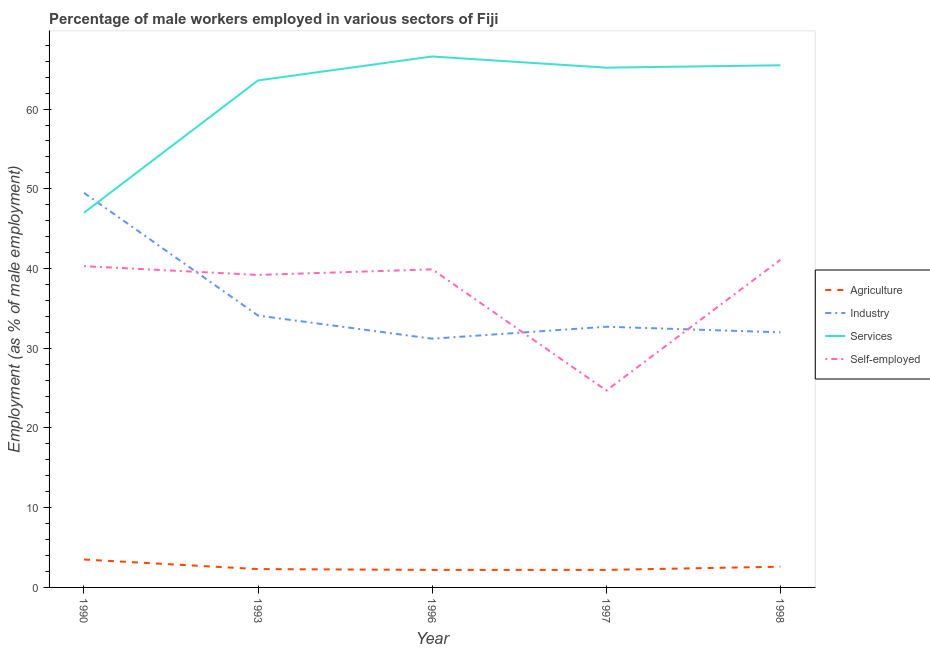What is the percentage of male workers in industry in 1996?
Provide a short and direct response. 31.2. Across all years, what is the maximum percentage of male workers in industry?
Keep it short and to the point. 49.5. Across all years, what is the minimum percentage of male workers in agriculture?
Your answer should be very brief. 2.2. In which year was the percentage of male workers in industry maximum?
Provide a succinct answer. 1990. What is the total percentage of male workers in industry in the graph?
Give a very brief answer. 179.5. What is the difference between the percentage of male workers in agriculture in 1990 and that in 1993?
Ensure brevity in your answer.  1.2. What is the difference between the percentage of self employed male workers in 1993 and the percentage of male workers in agriculture in 1996?
Make the answer very short. 37. What is the average percentage of male workers in services per year?
Make the answer very short. 61.58. In the year 1993, what is the difference between the percentage of male workers in services and percentage of male workers in agriculture?
Provide a short and direct response. 61.3. What is the ratio of the percentage of self employed male workers in 1993 to that in 1998?
Provide a short and direct response. 0.95. What is the difference between the highest and the second highest percentage of self employed male workers?
Give a very brief answer. 0.8. What is the difference between the highest and the lowest percentage of self employed male workers?
Offer a very short reply. 16.4. Is the sum of the percentage of self employed male workers in 1996 and 1998 greater than the maximum percentage of male workers in agriculture across all years?
Your answer should be very brief. Yes. Is it the case that in every year, the sum of the percentage of male workers in agriculture and percentage of male workers in industry is greater than the percentage of male workers in services?
Your answer should be very brief. No. Is the percentage of male workers in industry strictly greater than the percentage of self employed male workers over the years?
Keep it short and to the point. No. Is the percentage of self employed male workers strictly less than the percentage of male workers in industry over the years?
Your answer should be very brief. No. Are the values on the major ticks of Y-axis written in scientific E-notation?
Ensure brevity in your answer.  No. How many legend labels are there?
Your response must be concise. 4. What is the title of the graph?
Offer a very short reply. Percentage of male workers employed in various sectors of Fiji. What is the label or title of the X-axis?
Your response must be concise. Year. What is the label or title of the Y-axis?
Ensure brevity in your answer.  Employment (as % of male employment). What is the Employment (as % of male employment) of Agriculture in 1990?
Provide a short and direct response. 3.5. What is the Employment (as % of male employment) of Industry in 1990?
Make the answer very short. 49.5. What is the Employment (as % of male employment) in Self-employed in 1990?
Give a very brief answer. 40.3. What is the Employment (as % of male employment) in Agriculture in 1993?
Offer a very short reply. 2.3. What is the Employment (as % of male employment) of Industry in 1993?
Your response must be concise. 34.1. What is the Employment (as % of male employment) of Services in 1993?
Keep it short and to the point. 63.6. What is the Employment (as % of male employment) in Self-employed in 1993?
Your answer should be compact. 39.2. What is the Employment (as % of male employment) in Agriculture in 1996?
Provide a short and direct response. 2.2. What is the Employment (as % of male employment) in Industry in 1996?
Provide a succinct answer. 31.2. What is the Employment (as % of male employment) in Services in 1996?
Ensure brevity in your answer.  66.6. What is the Employment (as % of male employment) in Self-employed in 1996?
Your response must be concise. 39.9. What is the Employment (as % of male employment) of Agriculture in 1997?
Your response must be concise. 2.2. What is the Employment (as % of male employment) of Industry in 1997?
Give a very brief answer. 32.7. What is the Employment (as % of male employment) of Services in 1997?
Make the answer very short. 65.2. What is the Employment (as % of male employment) of Self-employed in 1997?
Offer a very short reply. 24.7. What is the Employment (as % of male employment) of Agriculture in 1998?
Provide a succinct answer. 2.6. What is the Employment (as % of male employment) of Industry in 1998?
Your response must be concise. 32. What is the Employment (as % of male employment) in Services in 1998?
Your answer should be compact. 65.5. What is the Employment (as % of male employment) of Self-employed in 1998?
Keep it short and to the point. 41.1. Across all years, what is the maximum Employment (as % of male employment) of Agriculture?
Keep it short and to the point. 3.5. Across all years, what is the maximum Employment (as % of male employment) in Industry?
Offer a terse response. 49.5. Across all years, what is the maximum Employment (as % of male employment) in Services?
Ensure brevity in your answer.  66.6. Across all years, what is the maximum Employment (as % of male employment) of Self-employed?
Offer a terse response. 41.1. Across all years, what is the minimum Employment (as % of male employment) of Agriculture?
Keep it short and to the point. 2.2. Across all years, what is the minimum Employment (as % of male employment) in Industry?
Offer a very short reply. 31.2. Across all years, what is the minimum Employment (as % of male employment) of Self-employed?
Keep it short and to the point. 24.7. What is the total Employment (as % of male employment) in Agriculture in the graph?
Your answer should be compact. 12.8. What is the total Employment (as % of male employment) in Industry in the graph?
Give a very brief answer. 179.5. What is the total Employment (as % of male employment) of Services in the graph?
Your response must be concise. 307.9. What is the total Employment (as % of male employment) in Self-employed in the graph?
Your answer should be very brief. 185.2. What is the difference between the Employment (as % of male employment) in Industry in 1990 and that in 1993?
Offer a very short reply. 15.4. What is the difference between the Employment (as % of male employment) of Services in 1990 and that in 1993?
Your answer should be very brief. -16.6. What is the difference between the Employment (as % of male employment) in Agriculture in 1990 and that in 1996?
Give a very brief answer. 1.3. What is the difference between the Employment (as % of male employment) of Services in 1990 and that in 1996?
Provide a short and direct response. -19.6. What is the difference between the Employment (as % of male employment) in Agriculture in 1990 and that in 1997?
Make the answer very short. 1.3. What is the difference between the Employment (as % of male employment) in Industry in 1990 and that in 1997?
Make the answer very short. 16.8. What is the difference between the Employment (as % of male employment) in Services in 1990 and that in 1997?
Offer a terse response. -18.2. What is the difference between the Employment (as % of male employment) in Self-employed in 1990 and that in 1997?
Give a very brief answer. 15.6. What is the difference between the Employment (as % of male employment) in Agriculture in 1990 and that in 1998?
Keep it short and to the point. 0.9. What is the difference between the Employment (as % of male employment) of Services in 1990 and that in 1998?
Keep it short and to the point. -18.5. What is the difference between the Employment (as % of male employment) in Self-employed in 1990 and that in 1998?
Offer a very short reply. -0.8. What is the difference between the Employment (as % of male employment) in Industry in 1993 and that in 1997?
Your response must be concise. 1.4. What is the difference between the Employment (as % of male employment) in Services in 1993 and that in 1997?
Make the answer very short. -1.6. What is the difference between the Employment (as % of male employment) in Self-employed in 1993 and that in 1997?
Provide a succinct answer. 14.5. What is the difference between the Employment (as % of male employment) in Agriculture in 1993 and that in 1998?
Make the answer very short. -0.3. What is the difference between the Employment (as % of male employment) in Services in 1993 and that in 1998?
Offer a terse response. -1.9. What is the difference between the Employment (as % of male employment) of Industry in 1996 and that in 1997?
Your response must be concise. -1.5. What is the difference between the Employment (as % of male employment) in Self-employed in 1996 and that in 1997?
Provide a short and direct response. 15.2. What is the difference between the Employment (as % of male employment) in Self-employed in 1996 and that in 1998?
Give a very brief answer. -1.2. What is the difference between the Employment (as % of male employment) in Industry in 1997 and that in 1998?
Your response must be concise. 0.7. What is the difference between the Employment (as % of male employment) of Self-employed in 1997 and that in 1998?
Give a very brief answer. -16.4. What is the difference between the Employment (as % of male employment) in Agriculture in 1990 and the Employment (as % of male employment) in Industry in 1993?
Your answer should be compact. -30.6. What is the difference between the Employment (as % of male employment) of Agriculture in 1990 and the Employment (as % of male employment) of Services in 1993?
Make the answer very short. -60.1. What is the difference between the Employment (as % of male employment) of Agriculture in 1990 and the Employment (as % of male employment) of Self-employed in 1993?
Provide a short and direct response. -35.7. What is the difference between the Employment (as % of male employment) in Industry in 1990 and the Employment (as % of male employment) in Services in 1993?
Provide a succinct answer. -14.1. What is the difference between the Employment (as % of male employment) of Services in 1990 and the Employment (as % of male employment) of Self-employed in 1993?
Ensure brevity in your answer.  7.8. What is the difference between the Employment (as % of male employment) in Agriculture in 1990 and the Employment (as % of male employment) in Industry in 1996?
Offer a very short reply. -27.7. What is the difference between the Employment (as % of male employment) of Agriculture in 1990 and the Employment (as % of male employment) of Services in 1996?
Your answer should be compact. -63.1. What is the difference between the Employment (as % of male employment) of Agriculture in 1990 and the Employment (as % of male employment) of Self-employed in 1996?
Offer a terse response. -36.4. What is the difference between the Employment (as % of male employment) of Industry in 1990 and the Employment (as % of male employment) of Services in 1996?
Provide a succinct answer. -17.1. What is the difference between the Employment (as % of male employment) in Agriculture in 1990 and the Employment (as % of male employment) in Industry in 1997?
Provide a succinct answer. -29.2. What is the difference between the Employment (as % of male employment) of Agriculture in 1990 and the Employment (as % of male employment) of Services in 1997?
Offer a terse response. -61.7. What is the difference between the Employment (as % of male employment) of Agriculture in 1990 and the Employment (as % of male employment) of Self-employed in 1997?
Make the answer very short. -21.2. What is the difference between the Employment (as % of male employment) of Industry in 1990 and the Employment (as % of male employment) of Services in 1997?
Offer a very short reply. -15.7. What is the difference between the Employment (as % of male employment) of Industry in 1990 and the Employment (as % of male employment) of Self-employed in 1997?
Offer a terse response. 24.8. What is the difference between the Employment (as % of male employment) in Services in 1990 and the Employment (as % of male employment) in Self-employed in 1997?
Offer a very short reply. 22.3. What is the difference between the Employment (as % of male employment) in Agriculture in 1990 and the Employment (as % of male employment) in Industry in 1998?
Your response must be concise. -28.5. What is the difference between the Employment (as % of male employment) of Agriculture in 1990 and the Employment (as % of male employment) of Services in 1998?
Ensure brevity in your answer.  -62. What is the difference between the Employment (as % of male employment) of Agriculture in 1990 and the Employment (as % of male employment) of Self-employed in 1998?
Provide a short and direct response. -37.6. What is the difference between the Employment (as % of male employment) of Industry in 1990 and the Employment (as % of male employment) of Services in 1998?
Your response must be concise. -16. What is the difference between the Employment (as % of male employment) of Industry in 1990 and the Employment (as % of male employment) of Self-employed in 1998?
Provide a succinct answer. 8.4. What is the difference between the Employment (as % of male employment) of Agriculture in 1993 and the Employment (as % of male employment) of Industry in 1996?
Keep it short and to the point. -28.9. What is the difference between the Employment (as % of male employment) in Agriculture in 1993 and the Employment (as % of male employment) in Services in 1996?
Make the answer very short. -64.3. What is the difference between the Employment (as % of male employment) of Agriculture in 1993 and the Employment (as % of male employment) of Self-employed in 1996?
Your answer should be compact. -37.6. What is the difference between the Employment (as % of male employment) of Industry in 1993 and the Employment (as % of male employment) of Services in 1996?
Give a very brief answer. -32.5. What is the difference between the Employment (as % of male employment) in Industry in 1993 and the Employment (as % of male employment) in Self-employed in 1996?
Your answer should be compact. -5.8. What is the difference between the Employment (as % of male employment) of Services in 1993 and the Employment (as % of male employment) of Self-employed in 1996?
Give a very brief answer. 23.7. What is the difference between the Employment (as % of male employment) in Agriculture in 1993 and the Employment (as % of male employment) in Industry in 1997?
Give a very brief answer. -30.4. What is the difference between the Employment (as % of male employment) of Agriculture in 1993 and the Employment (as % of male employment) of Services in 1997?
Offer a terse response. -62.9. What is the difference between the Employment (as % of male employment) of Agriculture in 1993 and the Employment (as % of male employment) of Self-employed in 1997?
Make the answer very short. -22.4. What is the difference between the Employment (as % of male employment) in Industry in 1993 and the Employment (as % of male employment) in Services in 1997?
Your answer should be very brief. -31.1. What is the difference between the Employment (as % of male employment) in Services in 1993 and the Employment (as % of male employment) in Self-employed in 1997?
Make the answer very short. 38.9. What is the difference between the Employment (as % of male employment) in Agriculture in 1993 and the Employment (as % of male employment) in Industry in 1998?
Offer a very short reply. -29.7. What is the difference between the Employment (as % of male employment) of Agriculture in 1993 and the Employment (as % of male employment) of Services in 1998?
Offer a very short reply. -63.2. What is the difference between the Employment (as % of male employment) in Agriculture in 1993 and the Employment (as % of male employment) in Self-employed in 1998?
Your answer should be very brief. -38.8. What is the difference between the Employment (as % of male employment) of Industry in 1993 and the Employment (as % of male employment) of Services in 1998?
Your answer should be compact. -31.4. What is the difference between the Employment (as % of male employment) in Services in 1993 and the Employment (as % of male employment) in Self-employed in 1998?
Offer a very short reply. 22.5. What is the difference between the Employment (as % of male employment) in Agriculture in 1996 and the Employment (as % of male employment) in Industry in 1997?
Make the answer very short. -30.5. What is the difference between the Employment (as % of male employment) of Agriculture in 1996 and the Employment (as % of male employment) of Services in 1997?
Provide a short and direct response. -63. What is the difference between the Employment (as % of male employment) of Agriculture in 1996 and the Employment (as % of male employment) of Self-employed in 1997?
Ensure brevity in your answer.  -22.5. What is the difference between the Employment (as % of male employment) in Industry in 1996 and the Employment (as % of male employment) in Services in 1997?
Offer a very short reply. -34. What is the difference between the Employment (as % of male employment) in Industry in 1996 and the Employment (as % of male employment) in Self-employed in 1997?
Give a very brief answer. 6.5. What is the difference between the Employment (as % of male employment) of Services in 1996 and the Employment (as % of male employment) of Self-employed in 1997?
Your answer should be very brief. 41.9. What is the difference between the Employment (as % of male employment) in Agriculture in 1996 and the Employment (as % of male employment) in Industry in 1998?
Keep it short and to the point. -29.8. What is the difference between the Employment (as % of male employment) of Agriculture in 1996 and the Employment (as % of male employment) of Services in 1998?
Offer a very short reply. -63.3. What is the difference between the Employment (as % of male employment) in Agriculture in 1996 and the Employment (as % of male employment) in Self-employed in 1998?
Give a very brief answer. -38.9. What is the difference between the Employment (as % of male employment) of Industry in 1996 and the Employment (as % of male employment) of Services in 1998?
Provide a succinct answer. -34.3. What is the difference between the Employment (as % of male employment) of Services in 1996 and the Employment (as % of male employment) of Self-employed in 1998?
Ensure brevity in your answer.  25.5. What is the difference between the Employment (as % of male employment) of Agriculture in 1997 and the Employment (as % of male employment) of Industry in 1998?
Give a very brief answer. -29.8. What is the difference between the Employment (as % of male employment) of Agriculture in 1997 and the Employment (as % of male employment) of Services in 1998?
Your answer should be compact. -63.3. What is the difference between the Employment (as % of male employment) in Agriculture in 1997 and the Employment (as % of male employment) in Self-employed in 1998?
Make the answer very short. -38.9. What is the difference between the Employment (as % of male employment) in Industry in 1997 and the Employment (as % of male employment) in Services in 1998?
Your answer should be very brief. -32.8. What is the difference between the Employment (as % of male employment) of Services in 1997 and the Employment (as % of male employment) of Self-employed in 1998?
Your answer should be very brief. 24.1. What is the average Employment (as % of male employment) in Agriculture per year?
Give a very brief answer. 2.56. What is the average Employment (as % of male employment) of Industry per year?
Your response must be concise. 35.9. What is the average Employment (as % of male employment) of Services per year?
Your response must be concise. 61.58. What is the average Employment (as % of male employment) in Self-employed per year?
Give a very brief answer. 37.04. In the year 1990, what is the difference between the Employment (as % of male employment) in Agriculture and Employment (as % of male employment) in Industry?
Your answer should be compact. -46. In the year 1990, what is the difference between the Employment (as % of male employment) in Agriculture and Employment (as % of male employment) in Services?
Your answer should be very brief. -43.5. In the year 1990, what is the difference between the Employment (as % of male employment) in Agriculture and Employment (as % of male employment) in Self-employed?
Offer a very short reply. -36.8. In the year 1990, what is the difference between the Employment (as % of male employment) in Industry and Employment (as % of male employment) in Self-employed?
Offer a terse response. 9.2. In the year 1993, what is the difference between the Employment (as % of male employment) in Agriculture and Employment (as % of male employment) in Industry?
Provide a short and direct response. -31.8. In the year 1993, what is the difference between the Employment (as % of male employment) in Agriculture and Employment (as % of male employment) in Services?
Your answer should be compact. -61.3. In the year 1993, what is the difference between the Employment (as % of male employment) in Agriculture and Employment (as % of male employment) in Self-employed?
Your response must be concise. -36.9. In the year 1993, what is the difference between the Employment (as % of male employment) in Industry and Employment (as % of male employment) in Services?
Provide a short and direct response. -29.5. In the year 1993, what is the difference between the Employment (as % of male employment) of Services and Employment (as % of male employment) of Self-employed?
Ensure brevity in your answer.  24.4. In the year 1996, what is the difference between the Employment (as % of male employment) of Agriculture and Employment (as % of male employment) of Services?
Make the answer very short. -64.4. In the year 1996, what is the difference between the Employment (as % of male employment) in Agriculture and Employment (as % of male employment) in Self-employed?
Your response must be concise. -37.7. In the year 1996, what is the difference between the Employment (as % of male employment) in Industry and Employment (as % of male employment) in Services?
Ensure brevity in your answer.  -35.4. In the year 1996, what is the difference between the Employment (as % of male employment) in Services and Employment (as % of male employment) in Self-employed?
Keep it short and to the point. 26.7. In the year 1997, what is the difference between the Employment (as % of male employment) in Agriculture and Employment (as % of male employment) in Industry?
Keep it short and to the point. -30.5. In the year 1997, what is the difference between the Employment (as % of male employment) in Agriculture and Employment (as % of male employment) in Services?
Ensure brevity in your answer.  -63. In the year 1997, what is the difference between the Employment (as % of male employment) in Agriculture and Employment (as % of male employment) in Self-employed?
Offer a very short reply. -22.5. In the year 1997, what is the difference between the Employment (as % of male employment) in Industry and Employment (as % of male employment) in Services?
Your response must be concise. -32.5. In the year 1997, what is the difference between the Employment (as % of male employment) of Services and Employment (as % of male employment) of Self-employed?
Provide a succinct answer. 40.5. In the year 1998, what is the difference between the Employment (as % of male employment) of Agriculture and Employment (as % of male employment) of Industry?
Keep it short and to the point. -29.4. In the year 1998, what is the difference between the Employment (as % of male employment) of Agriculture and Employment (as % of male employment) of Services?
Offer a terse response. -62.9. In the year 1998, what is the difference between the Employment (as % of male employment) of Agriculture and Employment (as % of male employment) of Self-employed?
Your answer should be very brief. -38.5. In the year 1998, what is the difference between the Employment (as % of male employment) of Industry and Employment (as % of male employment) of Services?
Provide a succinct answer. -33.5. In the year 1998, what is the difference between the Employment (as % of male employment) of Industry and Employment (as % of male employment) of Self-employed?
Give a very brief answer. -9.1. In the year 1998, what is the difference between the Employment (as % of male employment) of Services and Employment (as % of male employment) of Self-employed?
Your answer should be very brief. 24.4. What is the ratio of the Employment (as % of male employment) of Agriculture in 1990 to that in 1993?
Provide a short and direct response. 1.52. What is the ratio of the Employment (as % of male employment) in Industry in 1990 to that in 1993?
Give a very brief answer. 1.45. What is the ratio of the Employment (as % of male employment) in Services in 1990 to that in 1993?
Give a very brief answer. 0.74. What is the ratio of the Employment (as % of male employment) in Self-employed in 1990 to that in 1993?
Provide a short and direct response. 1.03. What is the ratio of the Employment (as % of male employment) in Agriculture in 1990 to that in 1996?
Offer a terse response. 1.59. What is the ratio of the Employment (as % of male employment) in Industry in 1990 to that in 1996?
Your response must be concise. 1.59. What is the ratio of the Employment (as % of male employment) in Services in 1990 to that in 1996?
Provide a succinct answer. 0.71. What is the ratio of the Employment (as % of male employment) in Agriculture in 1990 to that in 1997?
Provide a succinct answer. 1.59. What is the ratio of the Employment (as % of male employment) in Industry in 1990 to that in 1997?
Give a very brief answer. 1.51. What is the ratio of the Employment (as % of male employment) in Services in 1990 to that in 1997?
Offer a very short reply. 0.72. What is the ratio of the Employment (as % of male employment) in Self-employed in 1990 to that in 1997?
Ensure brevity in your answer.  1.63. What is the ratio of the Employment (as % of male employment) of Agriculture in 1990 to that in 1998?
Offer a very short reply. 1.35. What is the ratio of the Employment (as % of male employment) of Industry in 1990 to that in 1998?
Offer a terse response. 1.55. What is the ratio of the Employment (as % of male employment) in Services in 1990 to that in 1998?
Keep it short and to the point. 0.72. What is the ratio of the Employment (as % of male employment) in Self-employed in 1990 to that in 1998?
Your response must be concise. 0.98. What is the ratio of the Employment (as % of male employment) of Agriculture in 1993 to that in 1996?
Make the answer very short. 1.05. What is the ratio of the Employment (as % of male employment) of Industry in 1993 to that in 1996?
Offer a terse response. 1.09. What is the ratio of the Employment (as % of male employment) in Services in 1993 to that in 1996?
Offer a very short reply. 0.95. What is the ratio of the Employment (as % of male employment) in Self-employed in 1993 to that in 1996?
Provide a short and direct response. 0.98. What is the ratio of the Employment (as % of male employment) in Agriculture in 1993 to that in 1997?
Give a very brief answer. 1.05. What is the ratio of the Employment (as % of male employment) of Industry in 1993 to that in 1997?
Give a very brief answer. 1.04. What is the ratio of the Employment (as % of male employment) in Services in 1993 to that in 1997?
Your answer should be compact. 0.98. What is the ratio of the Employment (as % of male employment) in Self-employed in 1993 to that in 1997?
Your response must be concise. 1.59. What is the ratio of the Employment (as % of male employment) of Agriculture in 1993 to that in 1998?
Give a very brief answer. 0.88. What is the ratio of the Employment (as % of male employment) of Industry in 1993 to that in 1998?
Give a very brief answer. 1.07. What is the ratio of the Employment (as % of male employment) in Services in 1993 to that in 1998?
Your answer should be very brief. 0.97. What is the ratio of the Employment (as % of male employment) in Self-employed in 1993 to that in 1998?
Provide a succinct answer. 0.95. What is the ratio of the Employment (as % of male employment) of Agriculture in 1996 to that in 1997?
Keep it short and to the point. 1. What is the ratio of the Employment (as % of male employment) in Industry in 1996 to that in 1997?
Your response must be concise. 0.95. What is the ratio of the Employment (as % of male employment) of Services in 1996 to that in 1997?
Ensure brevity in your answer.  1.02. What is the ratio of the Employment (as % of male employment) of Self-employed in 1996 to that in 1997?
Your answer should be compact. 1.62. What is the ratio of the Employment (as % of male employment) in Agriculture in 1996 to that in 1998?
Your answer should be compact. 0.85. What is the ratio of the Employment (as % of male employment) of Industry in 1996 to that in 1998?
Keep it short and to the point. 0.97. What is the ratio of the Employment (as % of male employment) in Services in 1996 to that in 1998?
Offer a terse response. 1.02. What is the ratio of the Employment (as % of male employment) of Self-employed in 1996 to that in 1998?
Ensure brevity in your answer.  0.97. What is the ratio of the Employment (as % of male employment) of Agriculture in 1997 to that in 1998?
Make the answer very short. 0.85. What is the ratio of the Employment (as % of male employment) of Industry in 1997 to that in 1998?
Make the answer very short. 1.02. What is the ratio of the Employment (as % of male employment) in Services in 1997 to that in 1998?
Keep it short and to the point. 1. What is the ratio of the Employment (as % of male employment) in Self-employed in 1997 to that in 1998?
Your answer should be compact. 0.6. What is the difference between the highest and the second highest Employment (as % of male employment) of Industry?
Your answer should be compact. 15.4. What is the difference between the highest and the second highest Employment (as % of male employment) in Services?
Offer a very short reply. 1.1. What is the difference between the highest and the second highest Employment (as % of male employment) of Self-employed?
Provide a short and direct response. 0.8. What is the difference between the highest and the lowest Employment (as % of male employment) of Agriculture?
Your response must be concise. 1.3. What is the difference between the highest and the lowest Employment (as % of male employment) of Services?
Offer a terse response. 19.6. 